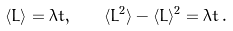<formula> <loc_0><loc_0><loc_500><loc_500>\langle L \rangle = \lambda t , \quad \langle L ^ { 2 } \rangle - \langle L \rangle ^ { 2 } = \lambda t \, .</formula> 